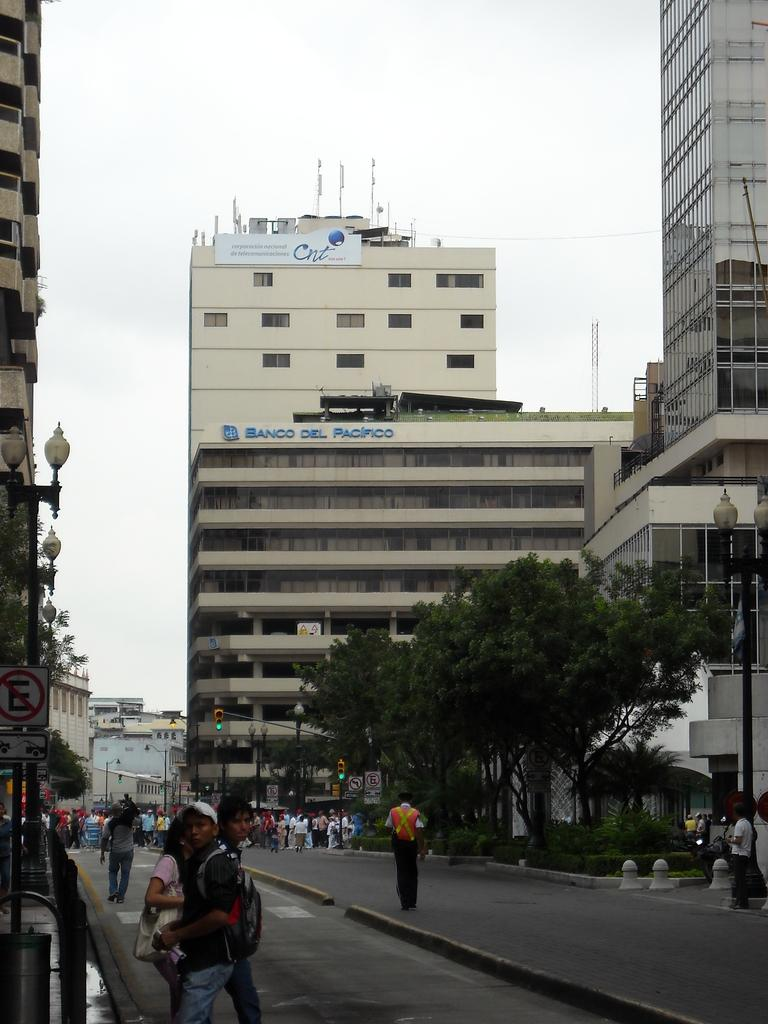<image>
Give a short and clear explanation of the subsequent image. the banco del Pacifico building stands tall in the city 